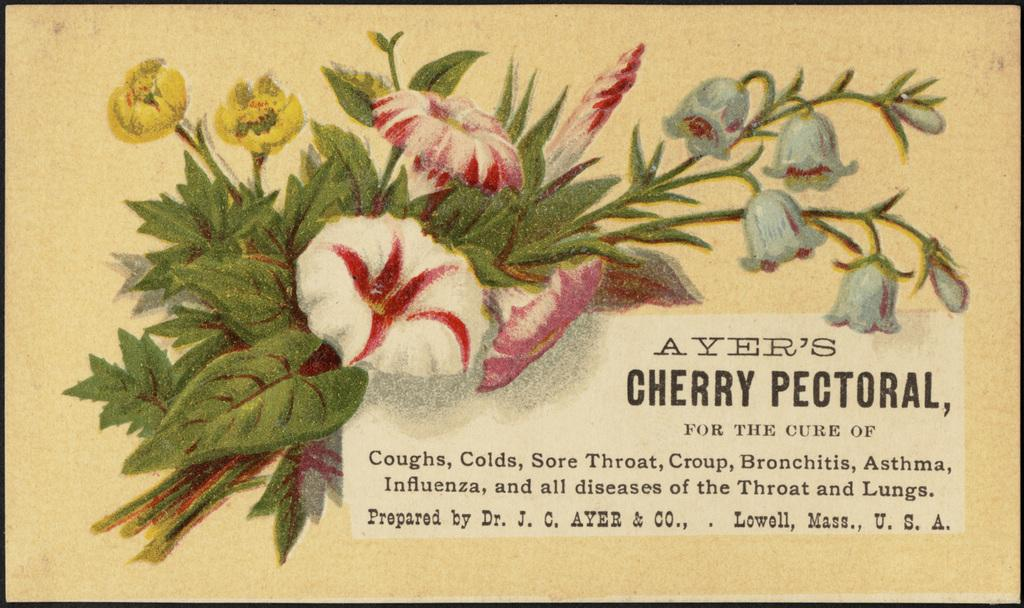What is depicted in the image through painting? There are flowers and leaves painted in the image. Can you describe the elements of nature that are present in the painting? The painting features flowers and leaves. Is there any text or writing in the image? Yes, there is something written at the right bottom of the image. How many fowl are depicted in the image? There are no fowl depicted in the image; it features flowers and leaves. What type of servant is shown assisting the person in the image? There is no person or servant present in the image; it is a painting of flowers and leaves with writing at the bottom. 